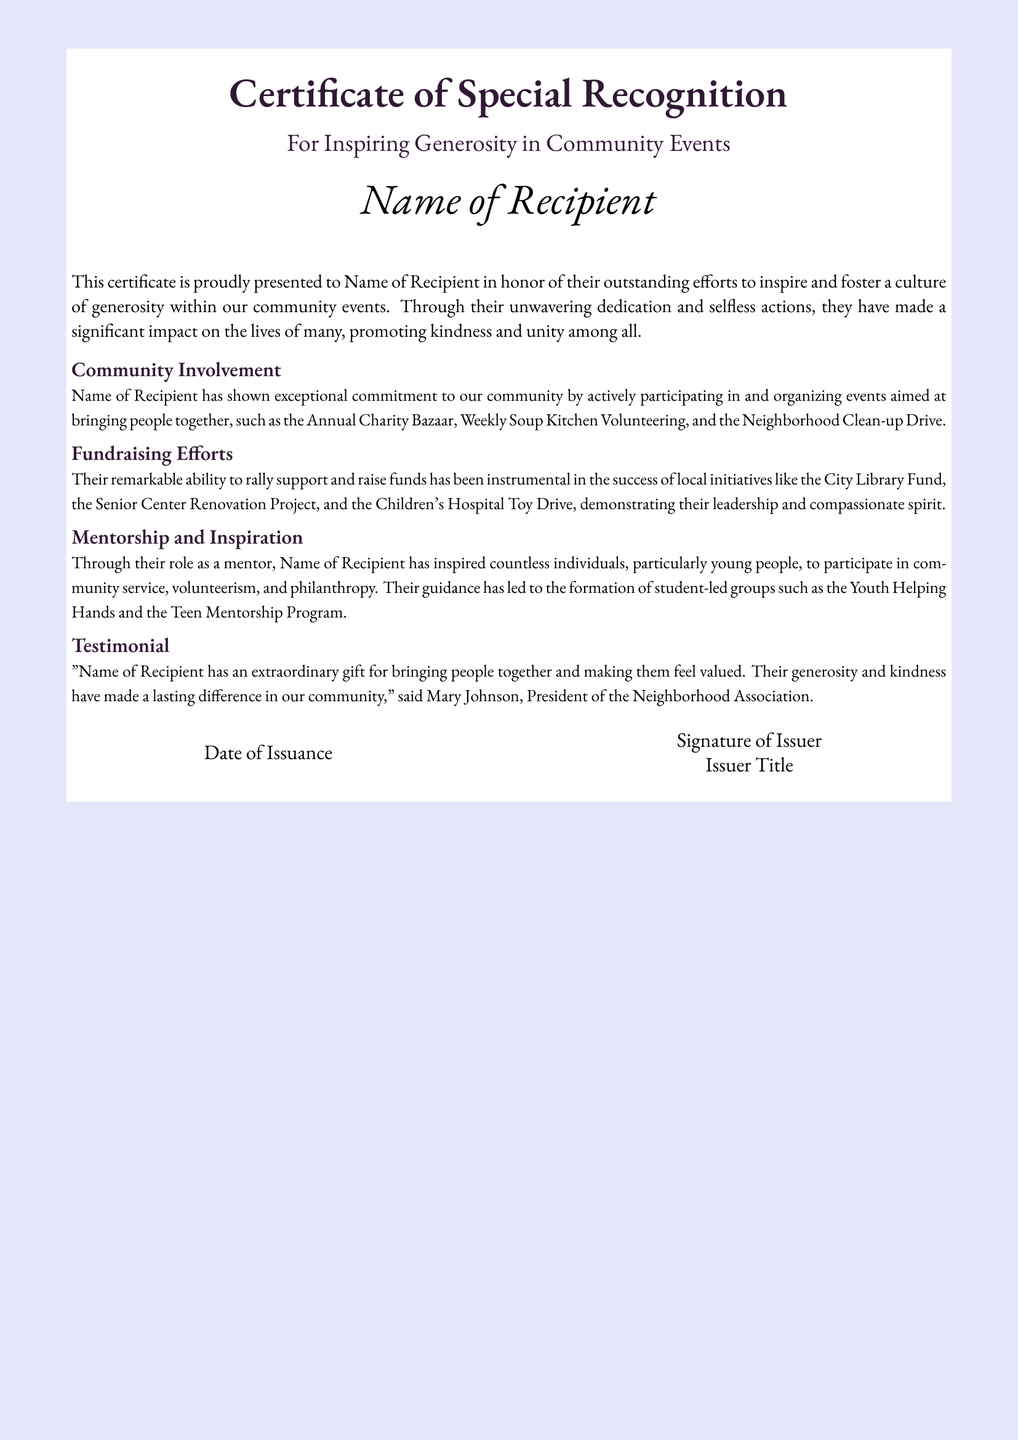What is the title of the certificate? The title is prominently displayed in a larger font, stating the purpose of recognition.
Answer: Certificate of Special Recognition Who is the recipient of the certificate? The recipient's name is indicated at the center of the document, highlighting who the certification is awarded to.
Answer: Name of Recipient What community event is mentioned for involvement? The certificate lists specific events where the recipient has contributed, showcasing their dedication to the community.
Answer: Annual Charity Bazaar What fundraising initiative is highlighted? It mentions a specific local initiative that the recipient has significantly supported through fundraising efforts.
Answer: City Library Fund Which group was inspired by the recipient’s mentorship? The document notes the formation of a specific group influenced by the recipient’s mentoring efforts.
Answer: Youth Helping Hands Who provided a testimonial about the recipient? A testimonial gives insight into the impact made by the recipient, including the name of the person who provided it.
Answer: Mary Johnson What is noted as a key quality of the recipient? The document describes a specific admirable quality attributed to the recipient, indicating their influence and actions.
Answer: Generosity When was the certificate issued? The issuance date is included in the document, providing a timeline for when the recognition was awarded.
Answer: Date of Issuance What is the color of the certificate's background? The background color of the certificate enhances its visual appeal and is a distinct feature of the design.
Answer: Lavender 